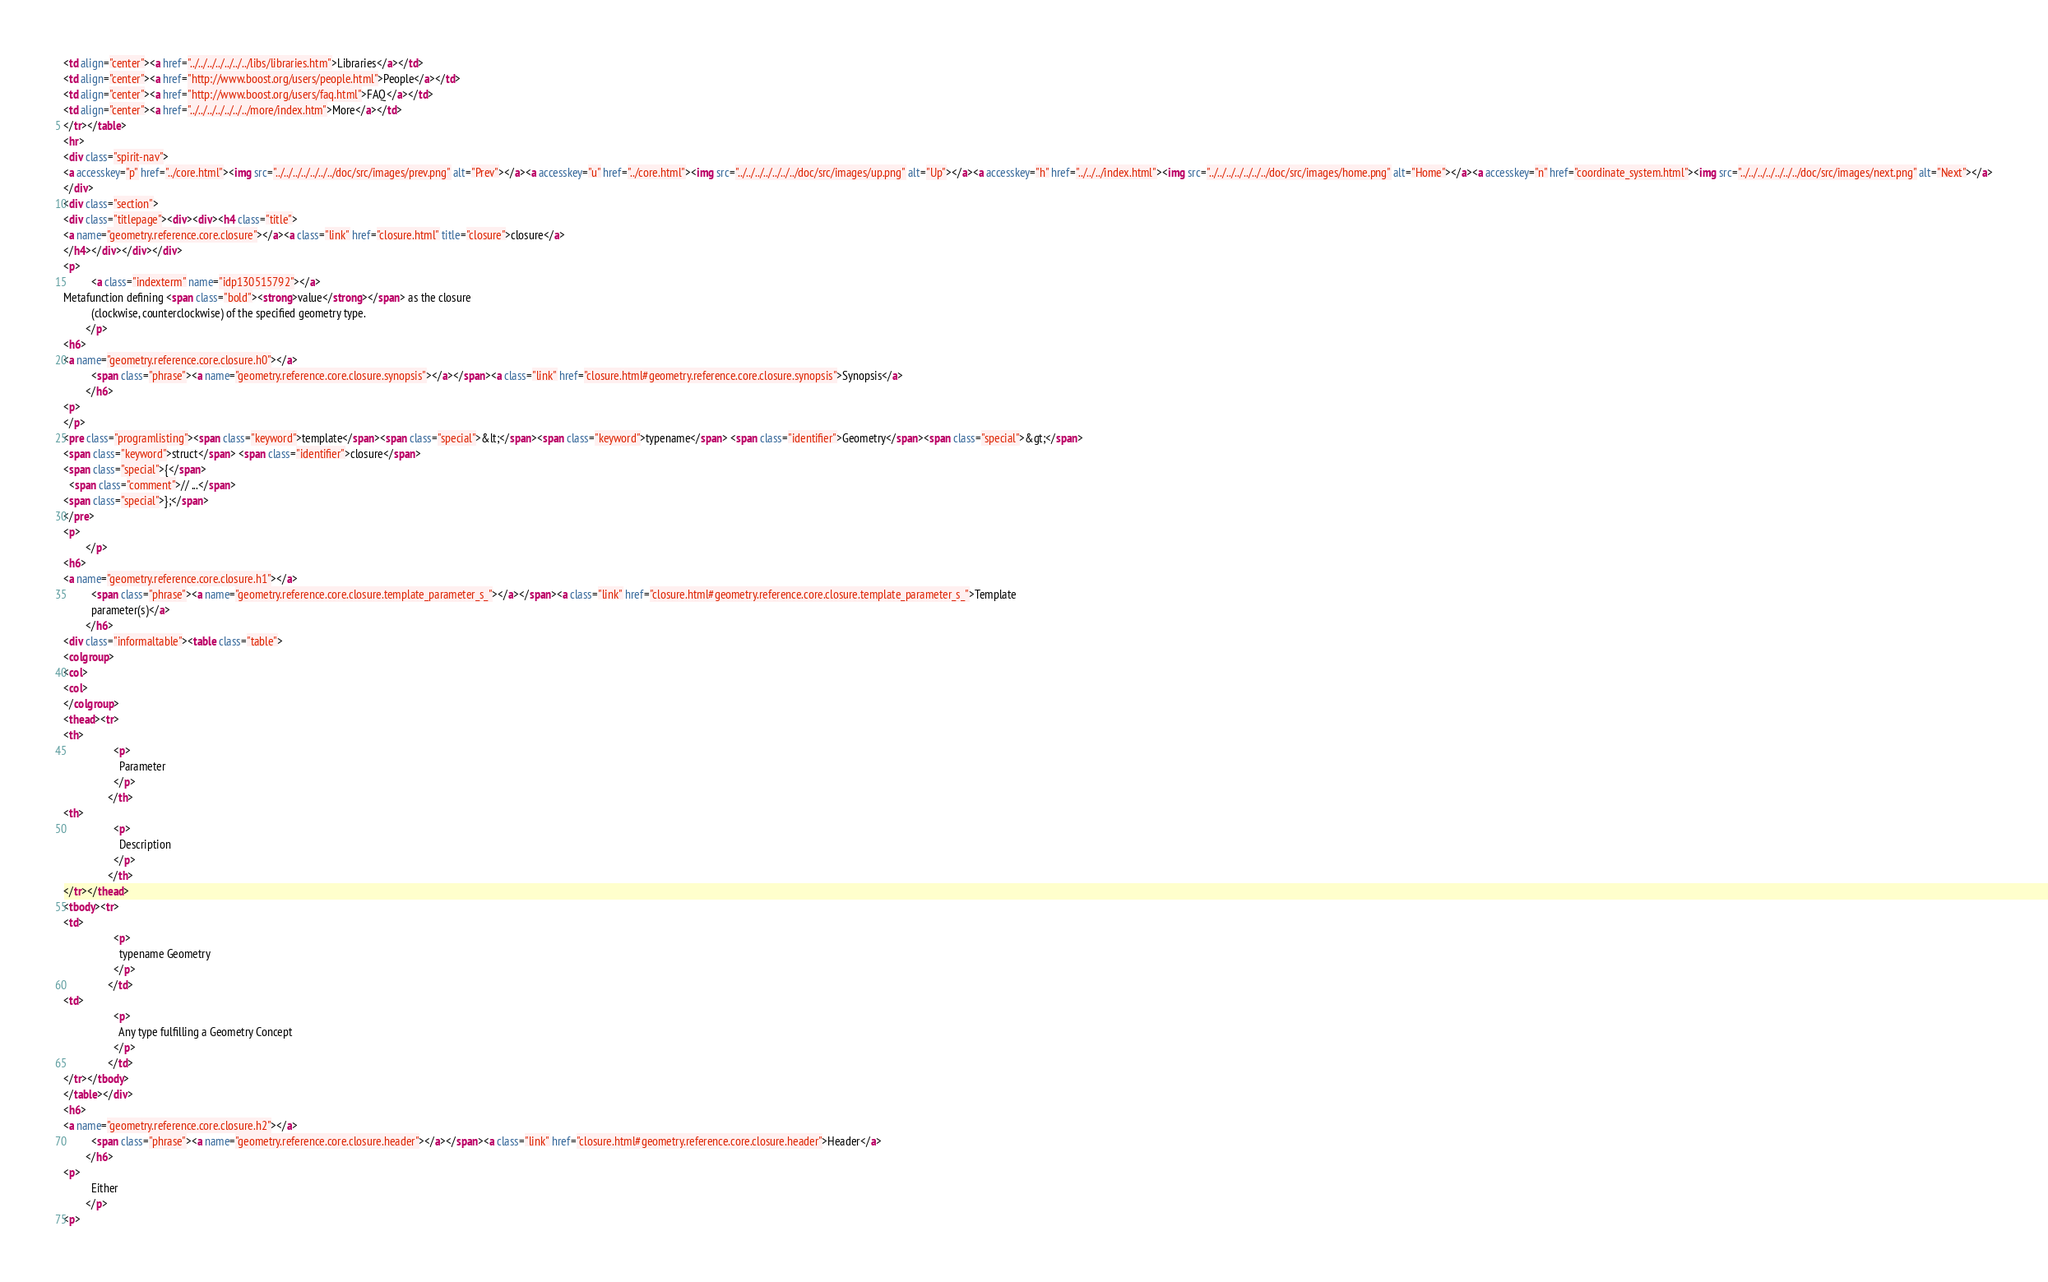<code> <loc_0><loc_0><loc_500><loc_500><_HTML_><td align="center"><a href="../../../../../../../libs/libraries.htm">Libraries</a></td>
<td align="center"><a href="http://www.boost.org/users/people.html">People</a></td>
<td align="center"><a href="http://www.boost.org/users/faq.html">FAQ</a></td>
<td align="center"><a href="../../../../../../../more/index.htm">More</a></td>
</tr></table>
<hr>
<div class="spirit-nav">
<a accesskey="p" href="../core.html"><img src="../../../../../../../doc/src/images/prev.png" alt="Prev"></a><a accesskey="u" href="../core.html"><img src="../../../../../../../doc/src/images/up.png" alt="Up"></a><a accesskey="h" href="../../../index.html"><img src="../../../../../../../doc/src/images/home.png" alt="Home"></a><a accesskey="n" href="coordinate_system.html"><img src="../../../../../../../doc/src/images/next.png" alt="Next"></a>
</div>
<div class="section">
<div class="titlepage"><div><div><h4 class="title">
<a name="geometry.reference.core.closure"></a><a class="link" href="closure.html" title="closure">closure</a>
</h4></div></div></div>
<p>
          <a class="indexterm" name="idp130515792"></a>
Metafunction defining <span class="bold"><strong>value</strong></span> as the closure
          (clockwise, counterclockwise) of the specified geometry type.
        </p>
<h6>
<a name="geometry.reference.core.closure.h0"></a>
          <span class="phrase"><a name="geometry.reference.core.closure.synopsis"></a></span><a class="link" href="closure.html#geometry.reference.core.closure.synopsis">Synopsis</a>
        </h6>
<p>
</p>
<pre class="programlisting"><span class="keyword">template</span><span class="special">&lt;</span><span class="keyword">typename</span> <span class="identifier">Geometry</span><span class="special">&gt;</span>
<span class="keyword">struct</span> <span class="identifier">closure</span>
<span class="special">{</span>
  <span class="comment">// ...</span>
<span class="special">};</span>
</pre>
<p>
        </p>
<h6>
<a name="geometry.reference.core.closure.h1"></a>
          <span class="phrase"><a name="geometry.reference.core.closure.template_parameter_s_"></a></span><a class="link" href="closure.html#geometry.reference.core.closure.template_parameter_s_">Template
          parameter(s)</a>
        </h6>
<div class="informaltable"><table class="table">
<colgroup>
<col>
<col>
</colgroup>
<thead><tr>
<th>
                  <p>
                    Parameter
                  </p>
                </th>
<th>
                  <p>
                    Description
                  </p>
                </th>
</tr></thead>
<tbody><tr>
<td>
                  <p>
                    typename Geometry
                  </p>
                </td>
<td>
                  <p>
                    Any type fulfilling a Geometry Concept
                  </p>
                </td>
</tr></tbody>
</table></div>
<h6>
<a name="geometry.reference.core.closure.h2"></a>
          <span class="phrase"><a name="geometry.reference.core.closure.header"></a></span><a class="link" href="closure.html#geometry.reference.core.closure.header">Header</a>
        </h6>
<p>
          Either
        </p>
<p></code> 